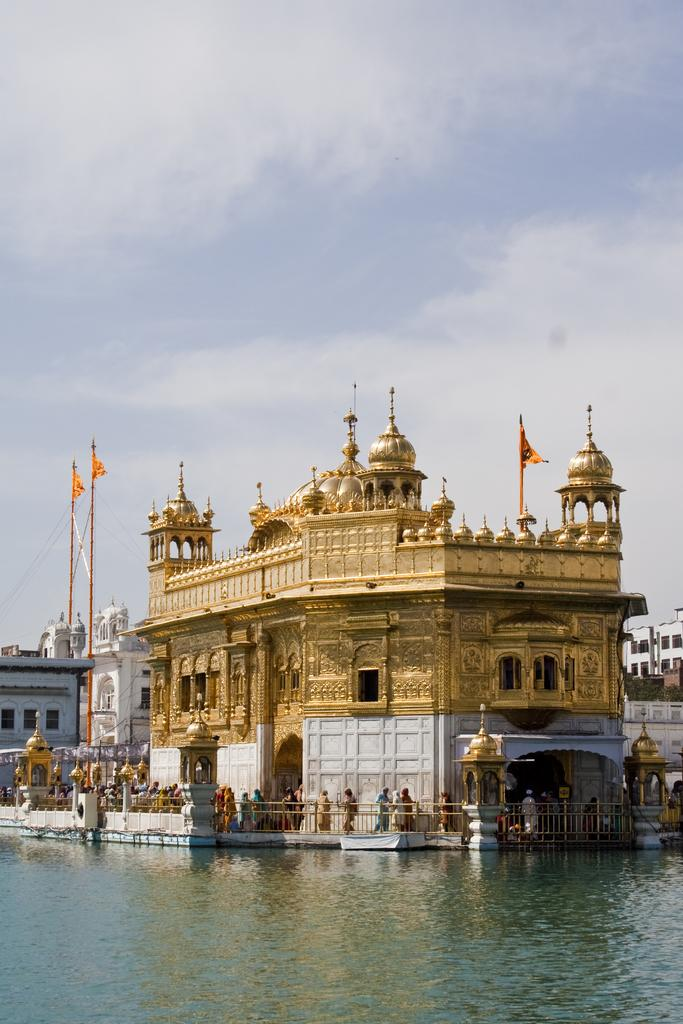What is in the front of the image? There is water in the front of the image. What is visible in the background of the image? The Golden Temple, poles, flags, buildings, and people are visible in the background. What can be seen in the sky in the image? There are clouds in the sky, and the sky is visible in the background. What type of sugar is being used to answer the questions about the image? There is no sugar involved in answering questions about the image; it is a conversation based on visual information. How does the breath of the people in the background affect the image? The breath of the people in the background does not affect the image; it is a still photograph. 